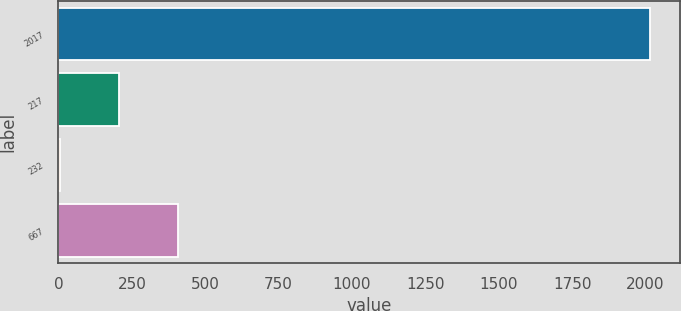Convert chart to OTSL. <chart><loc_0><loc_0><loc_500><loc_500><bar_chart><fcel>2017<fcel>217<fcel>232<fcel>667<nl><fcel>2015<fcel>205.17<fcel>4.08<fcel>406.26<nl></chart> 